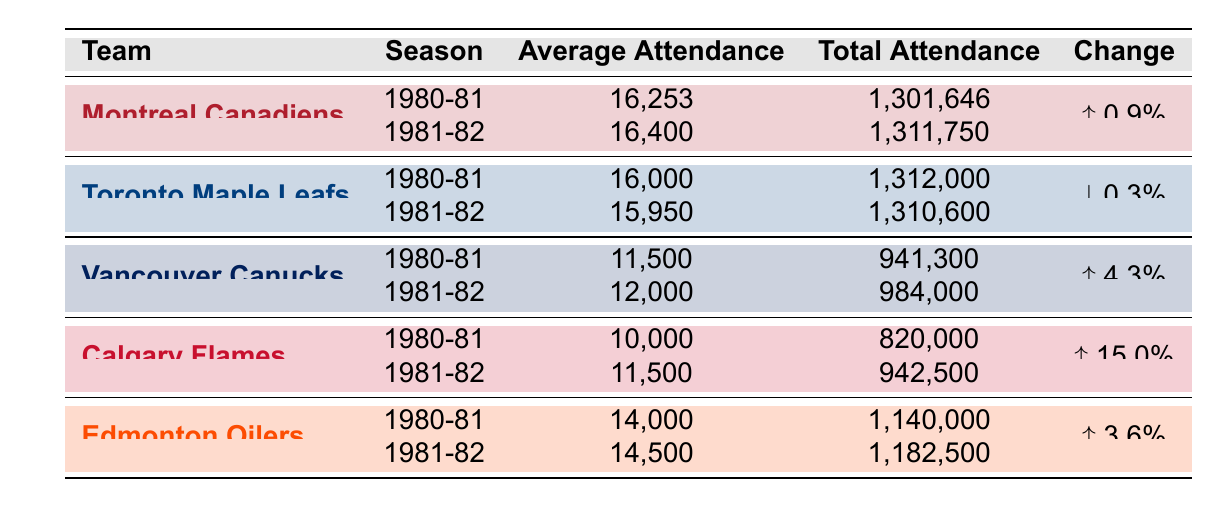What was the average attendance for the Montreal Canadiens in the 1981-82 season? The table shows that for the Montreal Canadiens in the 1981-82 season, the average attendance figure is listed as 16,400.
Answer: 16,400 Which Canadian NHL team had the highest average attendance in the 1980-81 season? Referring to the table, the Montreal Canadiens had the highest average attendance in the 1980-81 season at 16,253.
Answer: Montreal Canadiens Did the average attendance for the Vancouver Canucks increase from the 1980-81 season to the 1981-82 season? The table indicates that the average attendance for the Vancouver Canucks was 11,500 in the 1980-81 season and increased to 12,000 in the 1981-82 season, confirming the increase.
Answer: Yes What was the percentage change in average attendance for the Calgary Flames from the 1980-81 season to the 1981-82 season? The average attendance for the Calgary Flames was 10,000 in the 1980-81 season and increased to 11,500 in the 1981-82 season. To find the percentage change, use the formula: ((11,500 - 10,000) / 10,000) * 100 = 15%. Thus, the change is an increase of 15%.
Answer: 15% Which team had a decrease in average attendance from the 1980-81 season to the 1981-82 season? By examining the table, the Toronto Maple Leafs show a decrease in average attendance from 16,000 in the 1980-81 season to 15,950 in the 1981-82 season.
Answer: Toronto Maple Leafs What is the total attendance of the Edmonton Oilers for both seasons combined? Adding the total attendance for the Edmonton Oilers from the table: 1,140,000 (1980-81) + 1,182,500 (1981-82) = 2,322,500.
Answer: 2,322,500 Is it true that the Calgary Flames had higher average attendance than the Vancouver Canucks in both seasons? In 1980-81, Calgary's average was 10,000 and Vancouver's was 11,500; however, in 1981-82, Calgary's was 11,500 and Vancouver's was 12,000. Therefore, the statement is false, as Calgary had lower attendance in 1980-81.
Answer: No What was the average attendance percentage change for the Montreal Canadiens between the two seasons? The Montreal Canadiens' average attendance went from 16,253 in 1980-81 to 16,400 in 1981-82. The change is calculated as ((16,400 - 16,253) / 16,253) * 100 ≈ 0.9%. Thus, the Canadiens experienced a 0.9% increase in average attendance.
Answer: 0.9% 